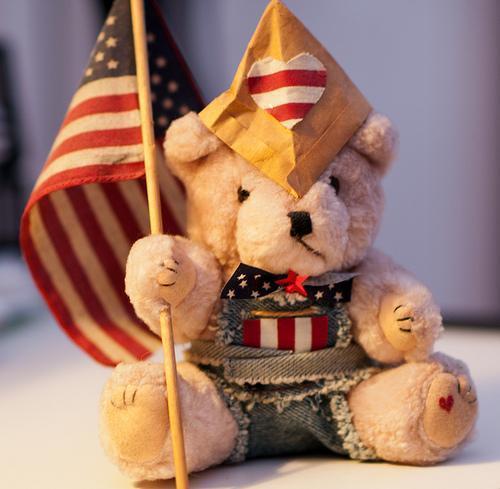How many teddy bears are there?
Give a very brief answer. 1. 